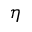<formula> <loc_0><loc_0><loc_500><loc_500>\eta</formula> 